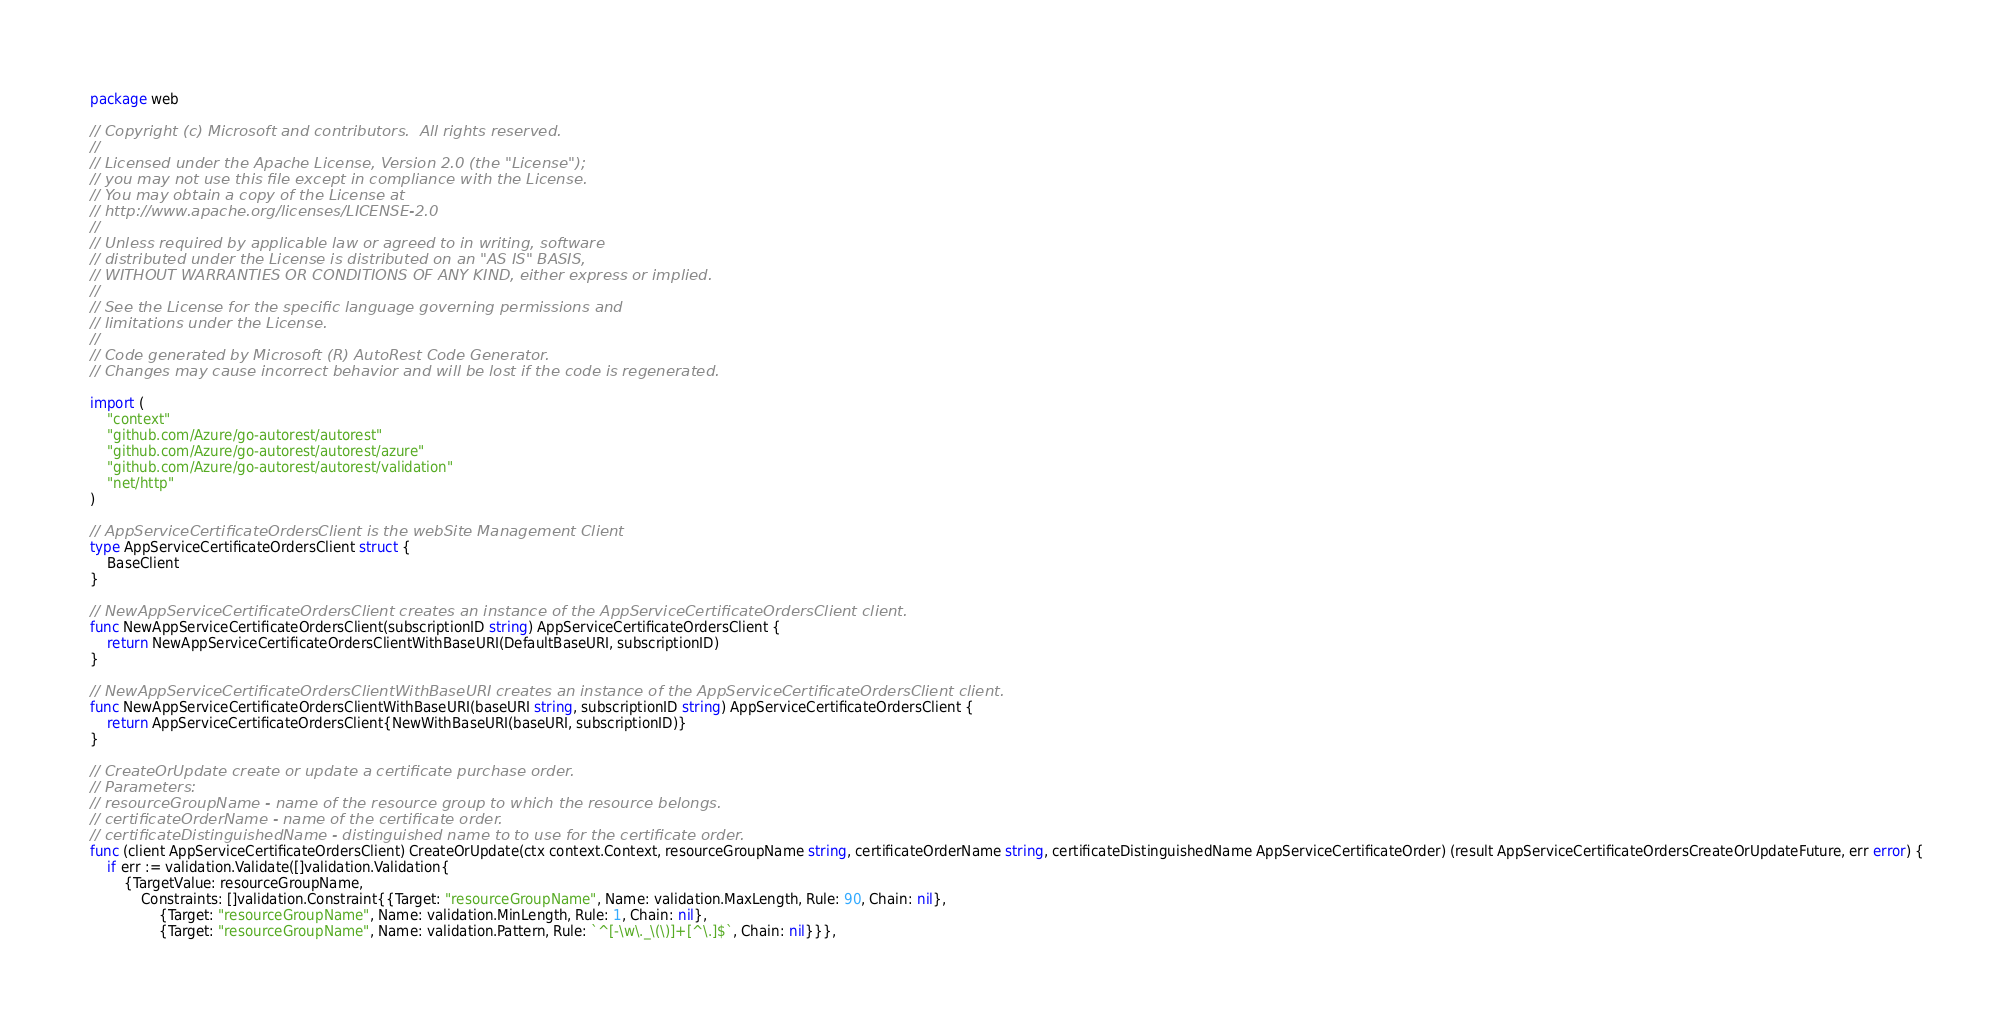<code> <loc_0><loc_0><loc_500><loc_500><_Go_>package web

// Copyright (c) Microsoft and contributors.  All rights reserved.
//
// Licensed under the Apache License, Version 2.0 (the "License");
// you may not use this file except in compliance with the License.
// You may obtain a copy of the License at
// http://www.apache.org/licenses/LICENSE-2.0
//
// Unless required by applicable law or agreed to in writing, software
// distributed under the License is distributed on an "AS IS" BASIS,
// WITHOUT WARRANTIES OR CONDITIONS OF ANY KIND, either express or implied.
//
// See the License for the specific language governing permissions and
// limitations under the License.
//
// Code generated by Microsoft (R) AutoRest Code Generator.
// Changes may cause incorrect behavior and will be lost if the code is regenerated.

import (
	"context"
	"github.com/Azure/go-autorest/autorest"
	"github.com/Azure/go-autorest/autorest/azure"
	"github.com/Azure/go-autorest/autorest/validation"
	"net/http"
)

// AppServiceCertificateOrdersClient is the webSite Management Client
type AppServiceCertificateOrdersClient struct {
	BaseClient
}

// NewAppServiceCertificateOrdersClient creates an instance of the AppServiceCertificateOrdersClient client.
func NewAppServiceCertificateOrdersClient(subscriptionID string) AppServiceCertificateOrdersClient {
	return NewAppServiceCertificateOrdersClientWithBaseURI(DefaultBaseURI, subscriptionID)
}

// NewAppServiceCertificateOrdersClientWithBaseURI creates an instance of the AppServiceCertificateOrdersClient client.
func NewAppServiceCertificateOrdersClientWithBaseURI(baseURI string, subscriptionID string) AppServiceCertificateOrdersClient {
	return AppServiceCertificateOrdersClient{NewWithBaseURI(baseURI, subscriptionID)}
}

// CreateOrUpdate create or update a certificate purchase order.
// Parameters:
// resourceGroupName - name of the resource group to which the resource belongs.
// certificateOrderName - name of the certificate order.
// certificateDistinguishedName - distinguished name to to use for the certificate order.
func (client AppServiceCertificateOrdersClient) CreateOrUpdate(ctx context.Context, resourceGroupName string, certificateOrderName string, certificateDistinguishedName AppServiceCertificateOrder) (result AppServiceCertificateOrdersCreateOrUpdateFuture, err error) {
	if err := validation.Validate([]validation.Validation{
		{TargetValue: resourceGroupName,
			Constraints: []validation.Constraint{{Target: "resourceGroupName", Name: validation.MaxLength, Rule: 90, Chain: nil},
				{Target: "resourceGroupName", Name: validation.MinLength, Rule: 1, Chain: nil},
				{Target: "resourceGroupName", Name: validation.Pattern, Rule: `^[-\w\._\(\)]+[^\.]$`, Chain: nil}}},</code> 